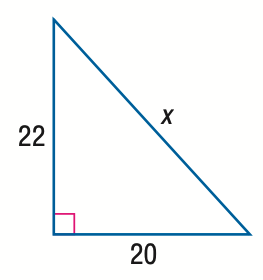Question: Find x.
Choices:
A. 2 \sqrt { 21 }
B. 20 \sqrt { 2 }
C. 2 \sqrt { 221 }
D. 22 \sqrt { 2 }
Answer with the letter. Answer: C 